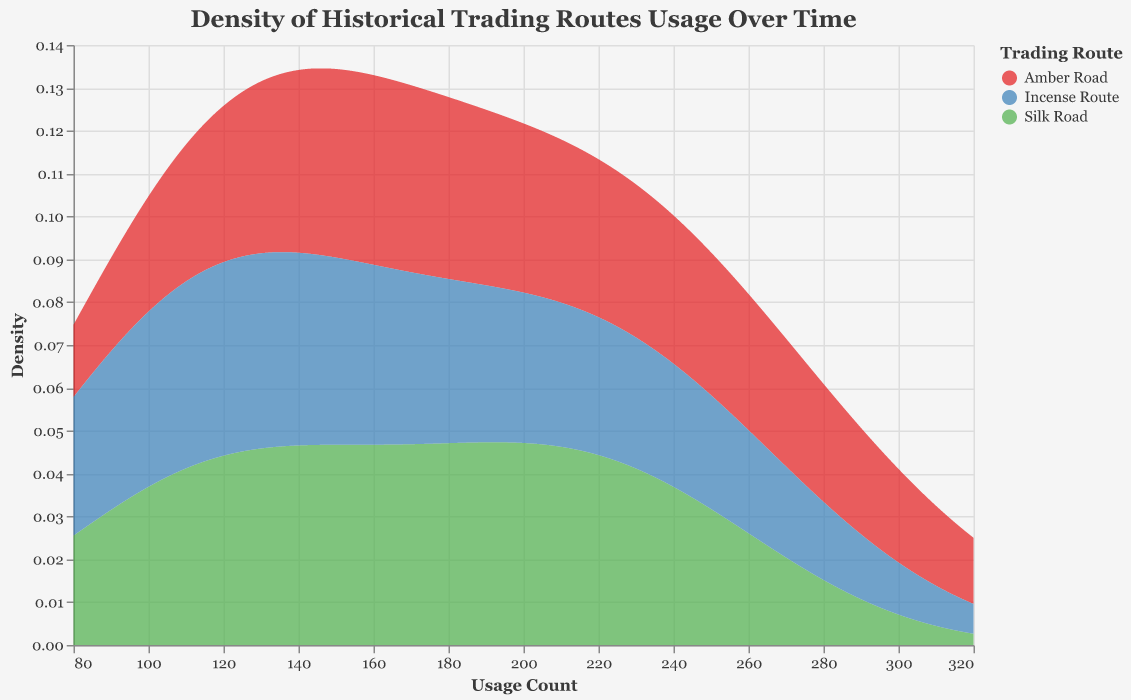What is the title of the plot? The plot title is provided at the top of the visualization, usually formatted to be easily noticeable. This is a basic observational question.
Answer: Density of Historical Trading Routes Usage Over Time What are the three trading routes represented in the plot? The routes are indicated by colors in the legend of the plot. This can be easily identified by looking at the color legend on the right or within the plot itself.
Answer: Silk Road, Amber Road, Incense Route Which trading route has the highest peak density in usage count? To identify the highest peak density, observe the y-axis (Density) values for each trading route's area in the plot. The route with the highest point on the y-axis has the highest peak density.
Answer: Amber Road In which range does the highest peak density occur for the Amber Road? Look for the highest peak of the Amber Road's area on the plot and refer to the x-axis to determine the corresponding usage count range.
Answer: Around 300 Usage Count Which trading route shows the most significant growth in usage from 1800 to 2000? To identify substantial growth, observe the spread and density peaks of each route over time by analyzing the densities' locations and trends on the x-axis.
Answer: Amber Road How many distinct color bands represent the trading routes, and what do these colors signify? Count the different colors used in the plot's area marks. The colors signify different trading routes, as identified by the legend on the right.
Answer: 3 colors, representing Silk Road, Amber Road, and Incense Route Compare the density of Incense Route and Silk Road at a usage count of 150. Which one has a higher density? Find the value of 150 on the x-axis and compare the corresponding y-axis values (density) for both trading routes at that point.
Answer: Silk Road What is the range of usage counts covered by the density plot? The x-axis represents the range of usage counts. Refer to the minimum and maximum values on the x-axis ticks.
Answer: 80 to 320 Which trading route shows the least fluctuation in density across the usage count range? Least fluctuation means having a more uniform density distribution. Observe the smoothness and spread of each area's density plot.
Answer: Incense Route Between 200 and 250 usage counts, which trading route has the highest density? Focus on the area between 200 and 250 on the x-axis, and then find the trading route with the highest y-axis (density) value in this range.
Answer: Amber Road 